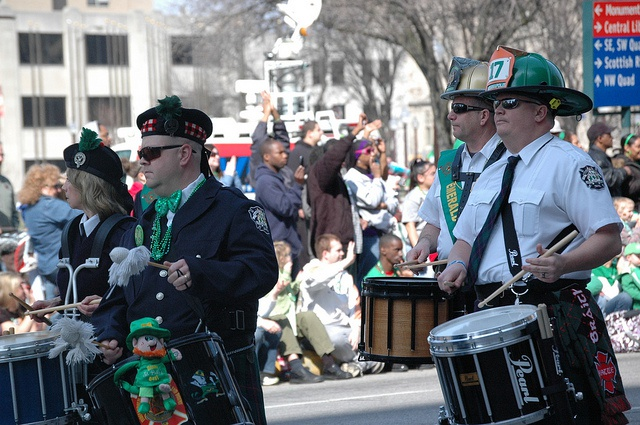Describe the objects in this image and their specific colors. I can see people in darkgray, black, gray, teal, and navy tones, people in darkgray, black, gray, and lightblue tones, people in darkgray, black, and gray tones, people in darkgray, gray, and black tones, and people in darkgray, white, and gray tones in this image. 